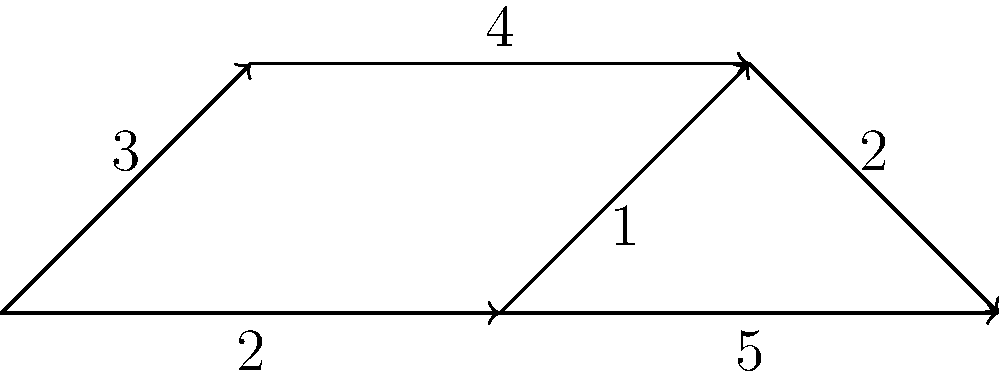In the context of game level design, the given weighted directed graph represents different areas of a level, where nodes are locations and edges are paths with associated traversal times. What is the shortest path from node A to node E, and what is its total weight? To find the shortest path from A to E, we can use Dijkstra's algorithm. Let's go through the process step-by-step:

1) Initialize distances: A(0), B(∞), C(∞), D(∞), E(∞)
   Initialize visited: {}
   Initialize previous: A(null), B(null), C(null), D(null), E(null)

2) Start from A:
   - Update B: dist[B] = min(∞, 0 + 3) = 3, prev[B] = A
   - Update C: dist[C] = min(∞, 0 + 2) = 2, prev[C] = A
   Visit A, visited = {A}

3) Choose the smallest unvisited node (C):
   - Update D: dist[D] = min(∞, 2 + 1) = 3, prev[D] = C
   - Update E: dist[E] = min(∞, 2 + 5) = 7, prev[E] = C
   Visit C, visited = {A, C}

4) Choose the smallest unvisited node (B or D, both 3):
   Choose B:
   - Update D: dist[D] = min(3, 3 + 4) = 3 (no change)
   Visit B, visited = {A, C, B}

5) Choose the smallest unvisited node (D):
   - Update E: dist[E] = min(7, 3 + 2) = 5, prev[E] = D
   Visit D, visited = {A, C, B, D}

6) Visit E, algorithm complete.

The shortest path is A → C → D → E with a total weight of 5.
Answer: A → C → D → E, weight 5 